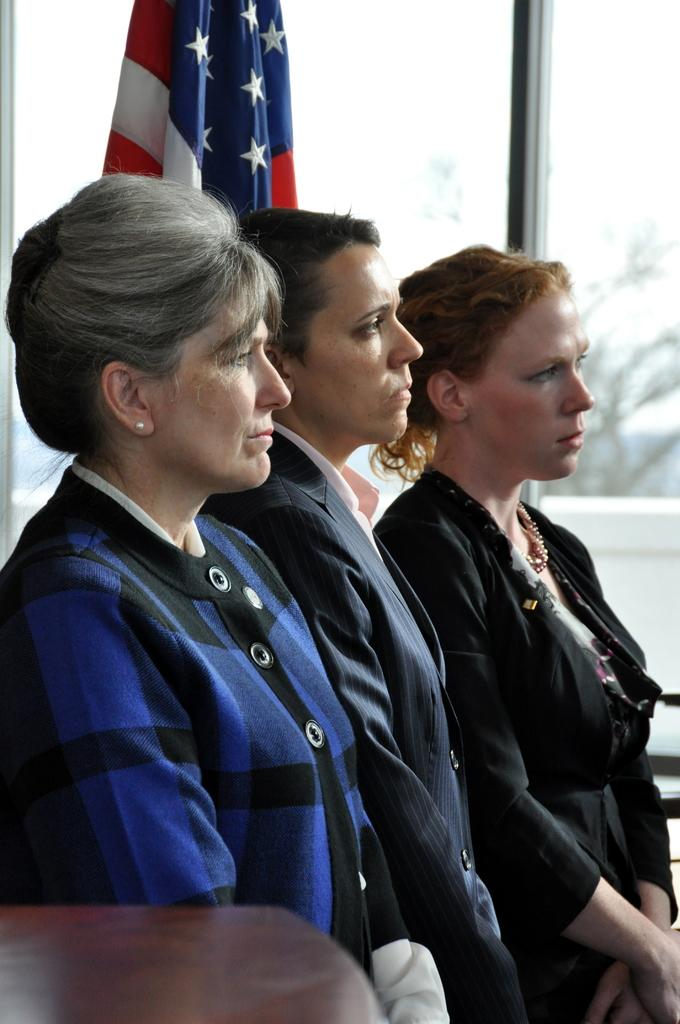Who is the main subject in the image? There is a woman in the center of the image. What can be seen in the background of the image? There is a flag, a tree, and windows in the background of the image. Can you see the moon in the image? No, the moon is not present in the image. Is there a volleyball game happening in the image? No, there is no volleyball game depicted in the image. 